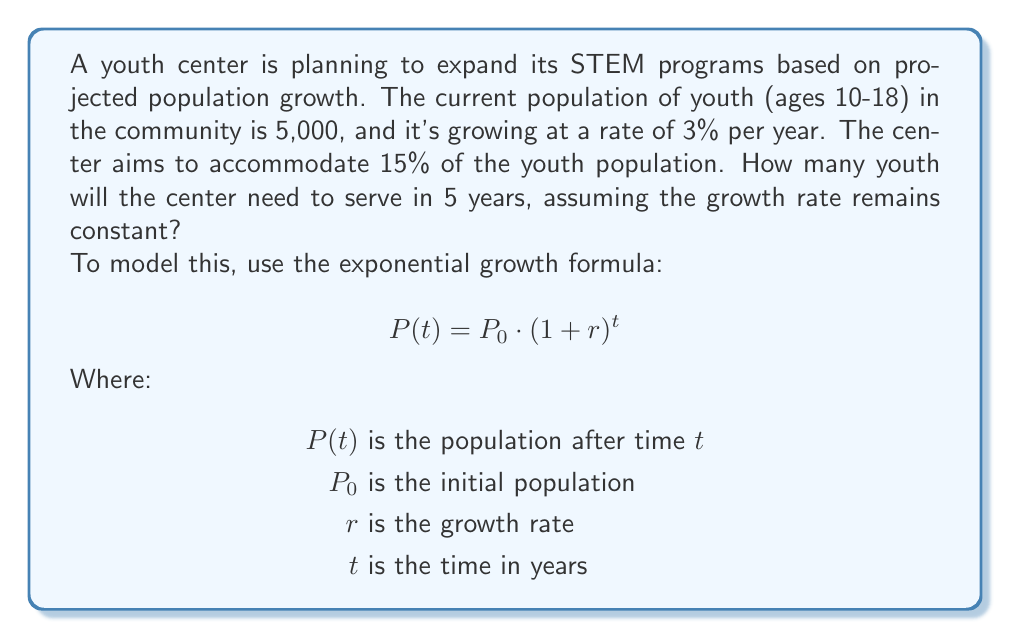Can you solve this math problem? Let's approach this step-by-step:

1) We're given:
   $P_0 = 5,000$ (initial youth population)
   $r = 0.03$ (3% growth rate)
   $t = 5$ years

2) Let's use the exponential growth formula to find the population after 5 years:

   $$P(5) = 5,000 \cdot (1 + 0.03)^5$$

3) Calculate:
   $$P(5) = 5,000 \cdot (1.03)^5 = 5,000 \cdot 1.159274$$
   $$P(5) = 5,796.37$$

4) Round down to the nearest whole number:
   $$P(5) \approx 5,796$$ youth

5) The center aims to accommodate 15% of this population:
   $$5,796 \cdot 0.15 = 869.4$$

6) Round up to the nearest whole number, as we can't serve a fraction of a youth:
   $$869.4 \approx 870$$ youth
Answer: 870 youth 